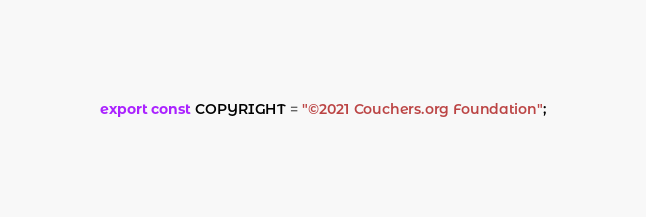<code> <loc_0><loc_0><loc_500><loc_500><_TypeScript_>export const COPYRIGHT = "©2021 Couchers.org Foundation";
</code> 